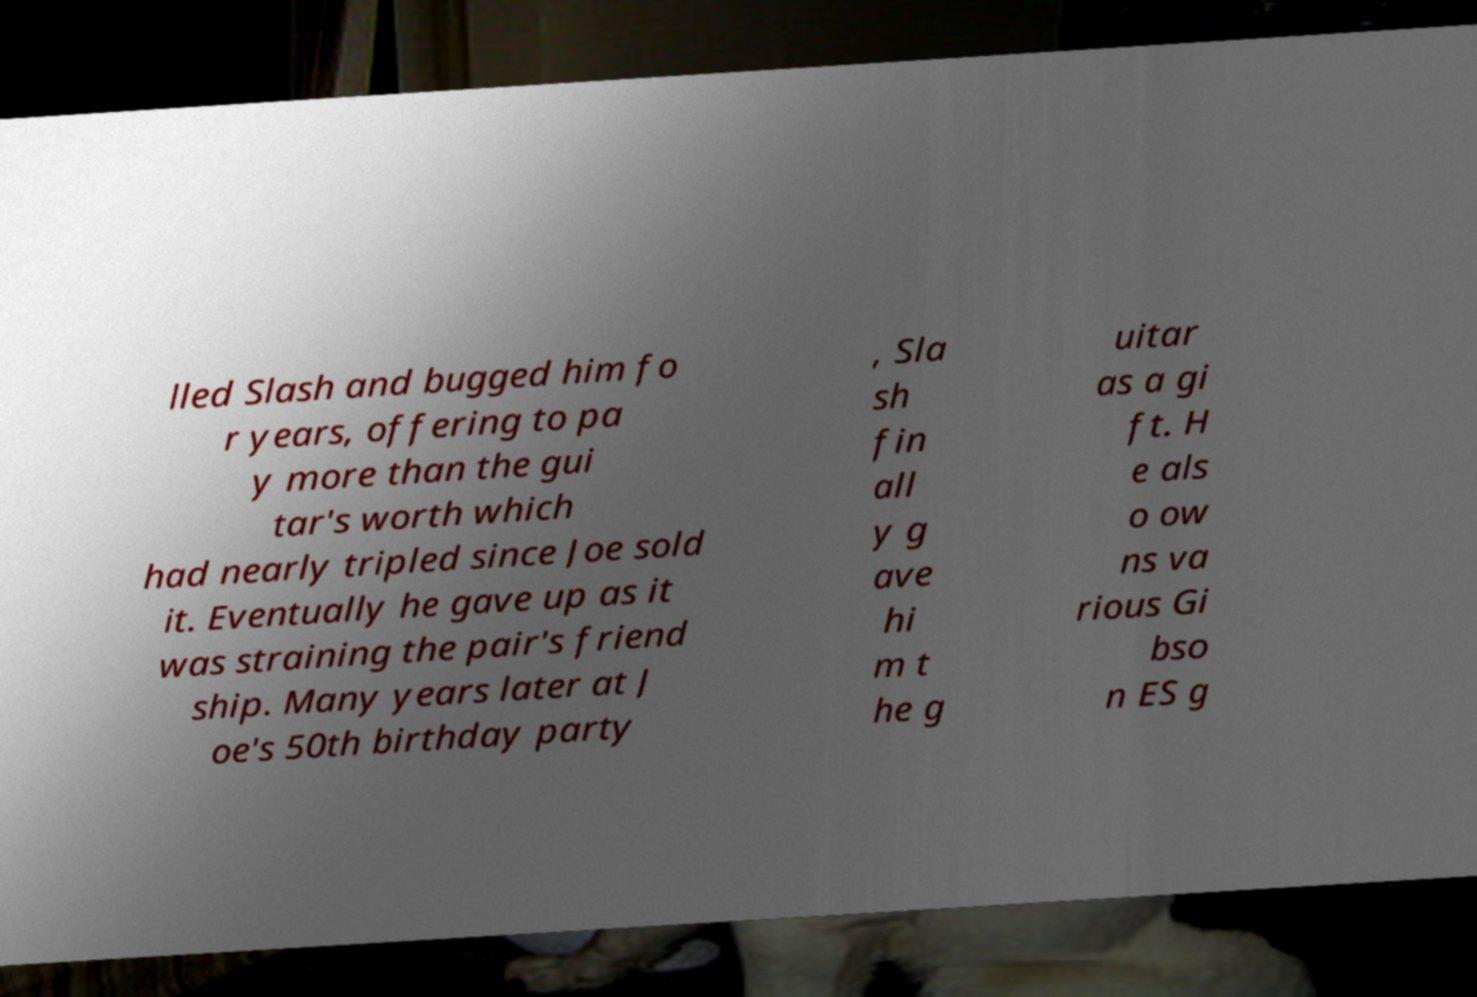Could you assist in decoding the text presented in this image and type it out clearly? lled Slash and bugged him fo r years, offering to pa y more than the gui tar's worth which had nearly tripled since Joe sold it. Eventually he gave up as it was straining the pair's friend ship. Many years later at J oe's 50th birthday party , Sla sh fin all y g ave hi m t he g uitar as a gi ft. H e als o ow ns va rious Gi bso n ES g 